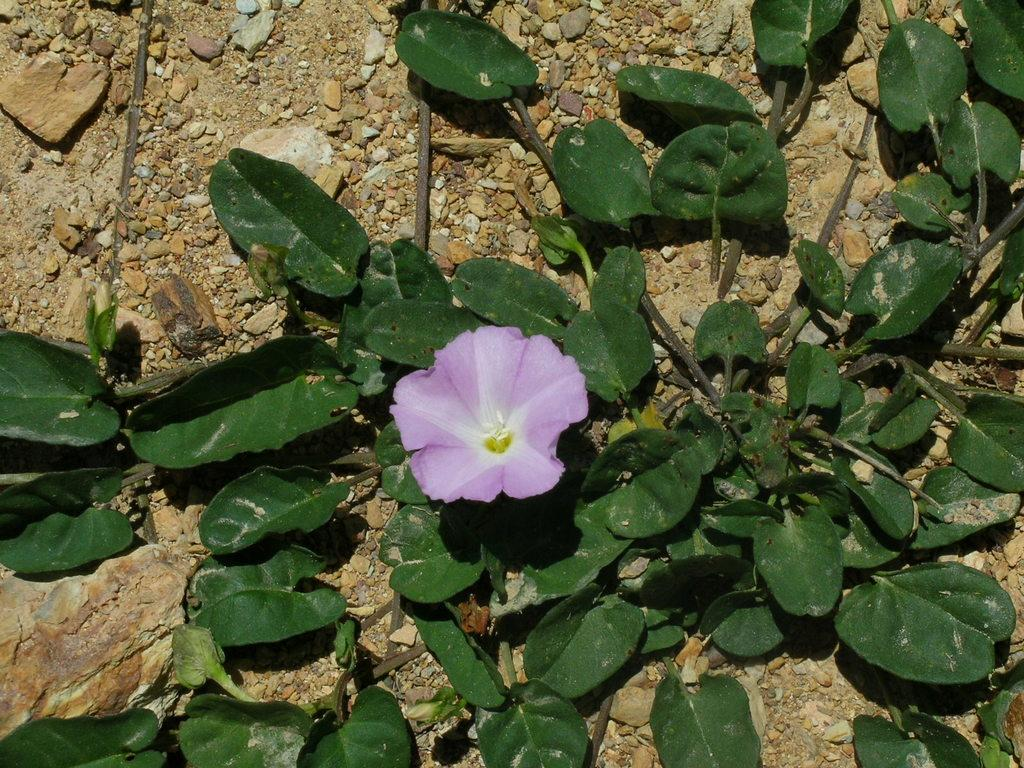What type of plant is visible in the image? There is a flower in the image. What else can be seen in the image besides the flower? There is another plant visible in the image. What is the surface on which the plants are situated? The ground is visible in the image. What type of material is present in the image? There are stones in the image. What type of prose can be heard in the image? There is no prose present in the image, as it is a visual representation and does not contain any spoken or written language. 